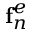Convert formula to latex. <formula><loc_0><loc_0><loc_500><loc_500>f _ { n } ^ { e }</formula> 